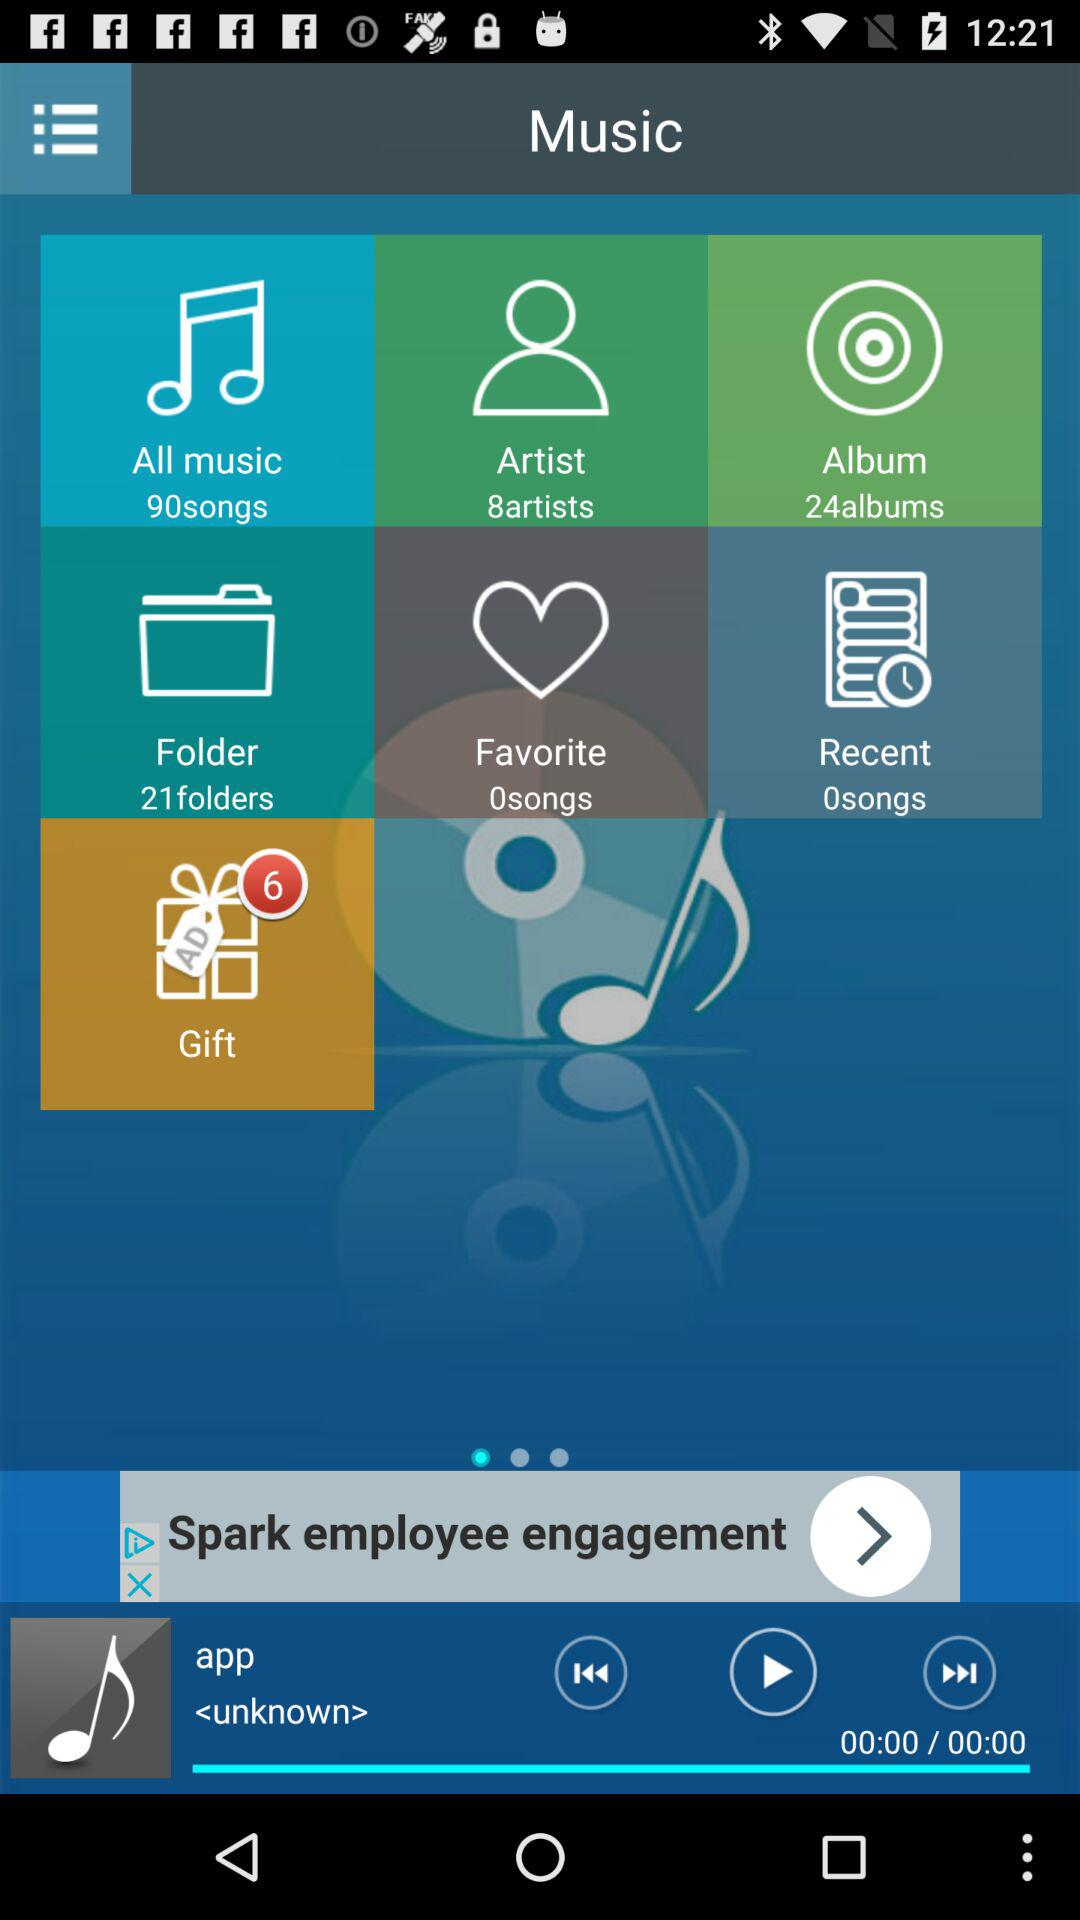How many artists are there in the folder "Artist"? There are 8 artists. 